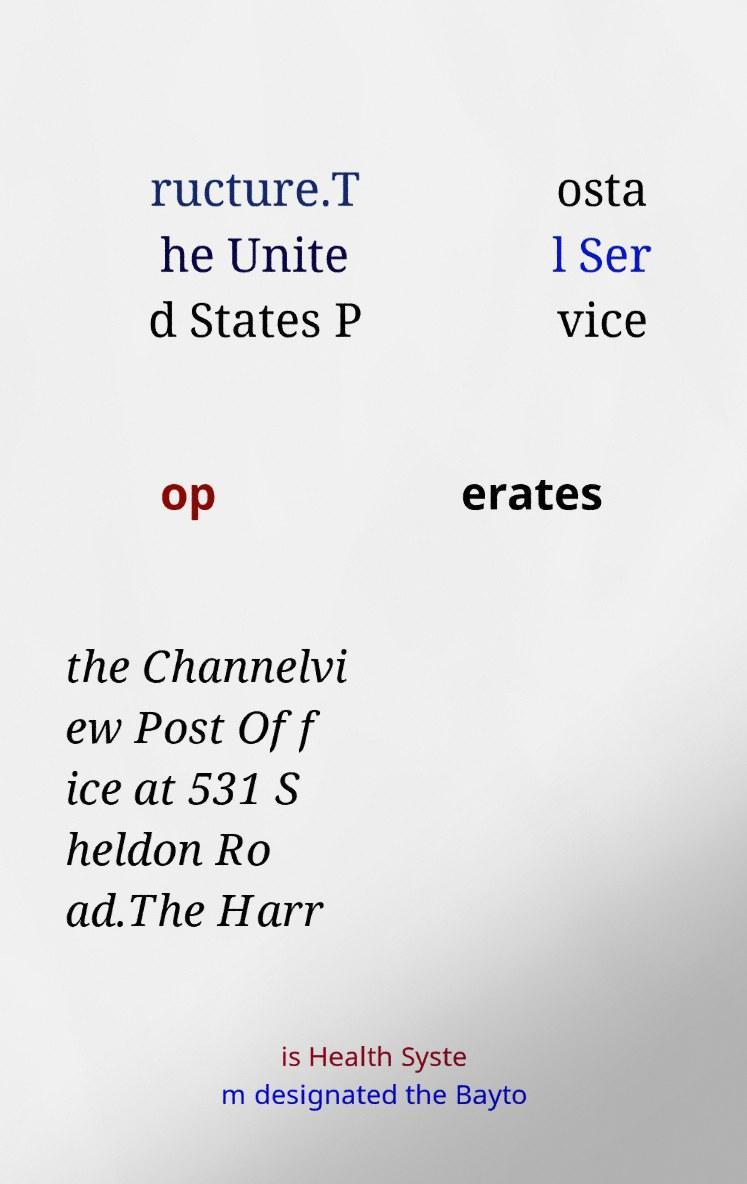I need the written content from this picture converted into text. Can you do that? ructure.T he Unite d States P osta l Ser vice op erates the Channelvi ew Post Off ice at 531 S heldon Ro ad.The Harr is Health Syste m designated the Bayto 